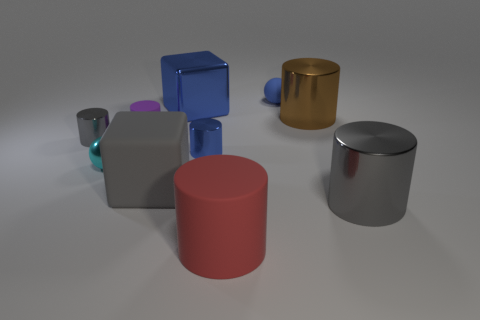Subtract 2 cylinders. How many cylinders are left? 4 Subtract all blue cylinders. How many cylinders are left? 5 Subtract all brown shiny cylinders. How many cylinders are left? 5 Subtract all purple cylinders. Subtract all purple cubes. How many cylinders are left? 5 Subtract all spheres. How many objects are left? 8 Add 8 tiny gray things. How many tiny gray things exist? 9 Subtract 1 blue blocks. How many objects are left? 9 Subtract all small blue metal things. Subtract all blue rubber objects. How many objects are left? 8 Add 1 purple cylinders. How many purple cylinders are left? 2 